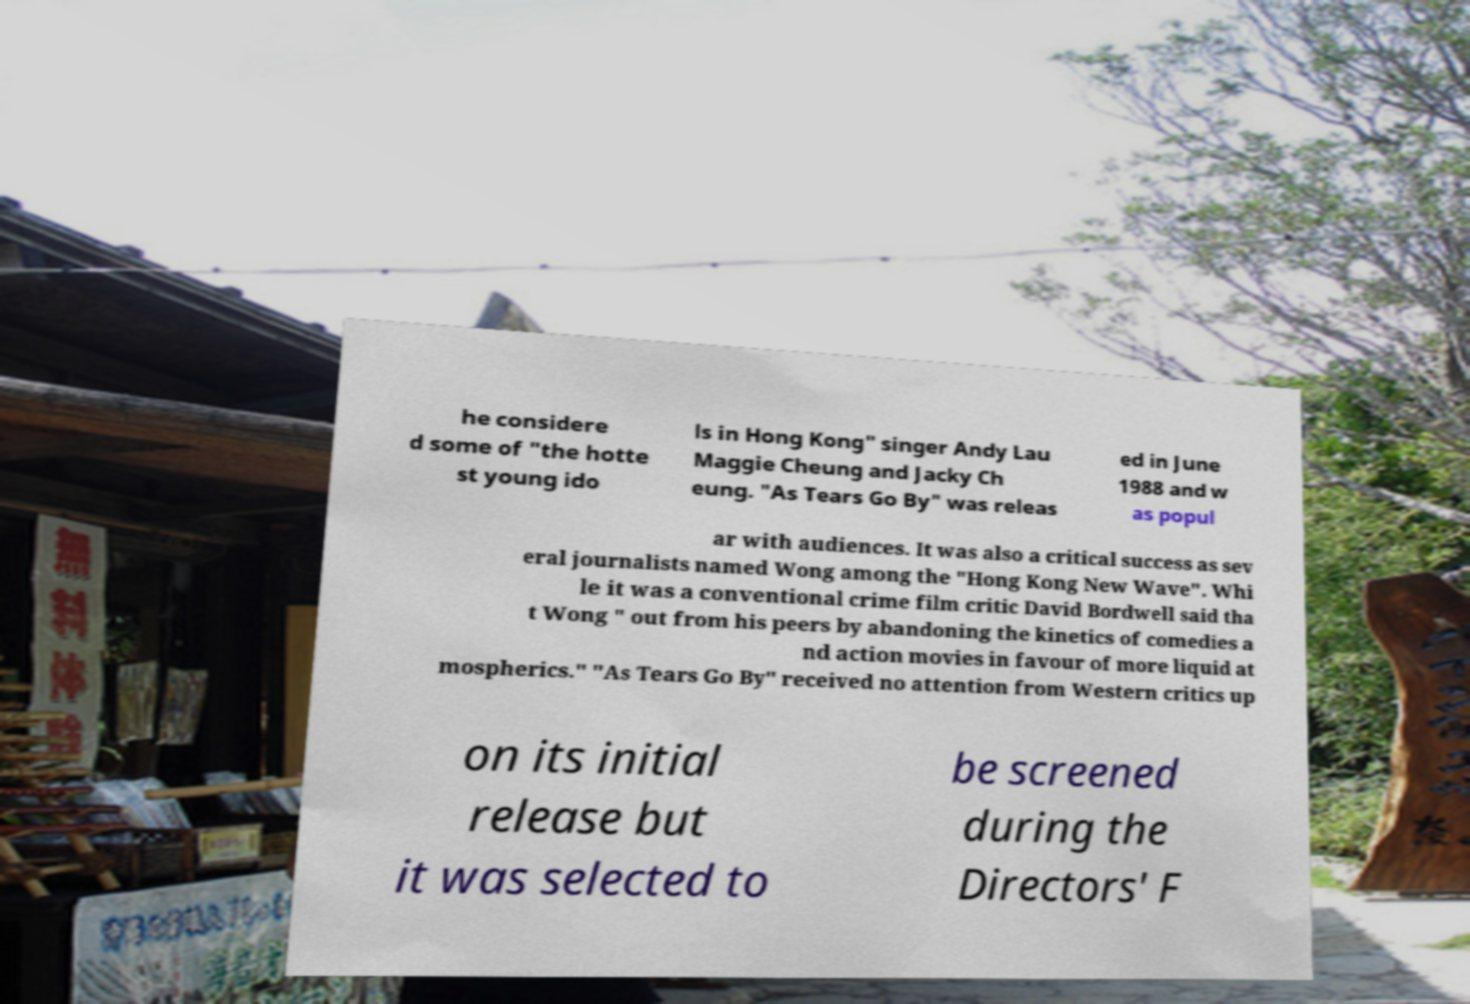Can you read and provide the text displayed in the image?This photo seems to have some interesting text. Can you extract and type it out for me? he considere d some of "the hotte st young ido ls in Hong Kong" singer Andy Lau Maggie Cheung and Jacky Ch eung. "As Tears Go By" was releas ed in June 1988 and w as popul ar with audiences. It was also a critical success as sev eral journalists named Wong among the "Hong Kong New Wave". Whi le it was a conventional crime film critic David Bordwell said tha t Wong " out from his peers by abandoning the kinetics of comedies a nd action movies in favour of more liquid at mospherics." "As Tears Go By" received no attention from Western critics up on its initial release but it was selected to be screened during the Directors' F 